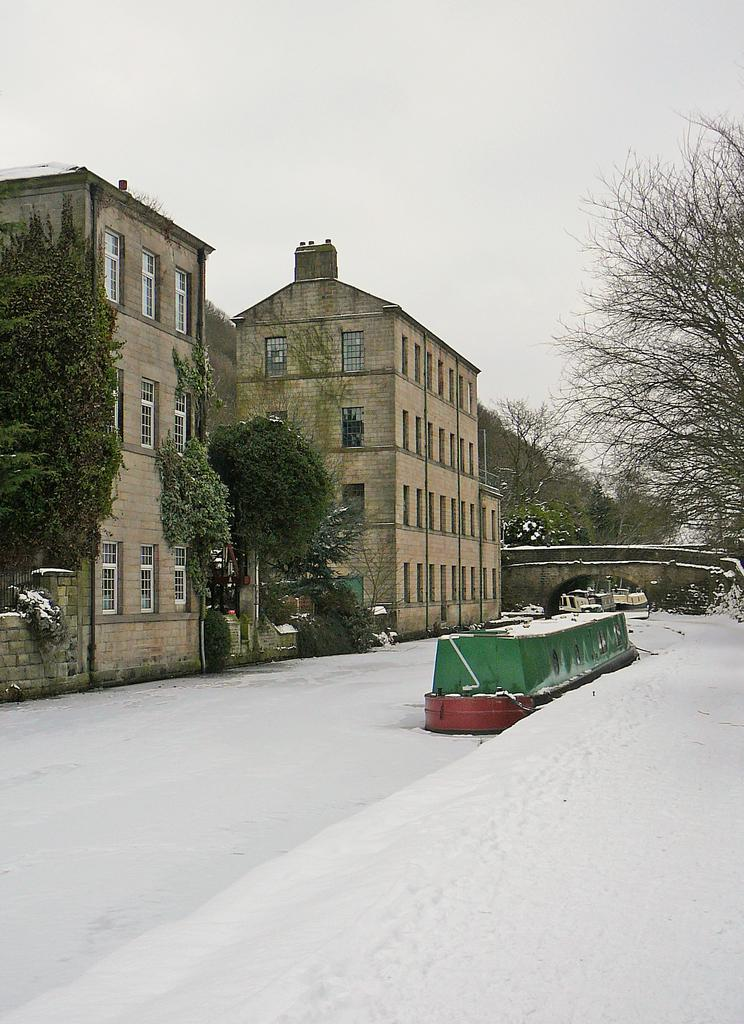What is the main feature of the image? There is a road in the image. Is there any specific vehicle on the road? There may be a tank on the road. What else can be seen in the middle of the image? There are buildings in the middle of the image. What type of structure is visible in the image? There is a bridge visible in the image. What type of vegetation is present in the image? Trees are present in the image. What is visible at the top of the image? The sky is visible at the top of the image. Where is the store located in the image? There is no store present in the image. Can you tell me how many times the mom appears in the image? There is no mom present in the image. 